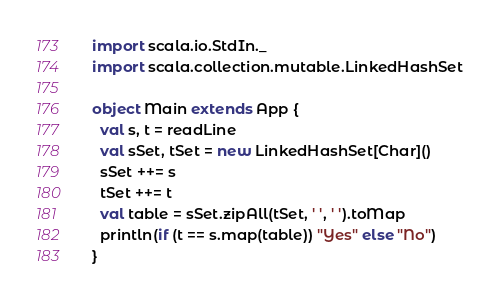<code> <loc_0><loc_0><loc_500><loc_500><_Scala_>import scala.io.StdIn._
import scala.collection.mutable.LinkedHashSet

object Main extends App {
  val s, t = readLine
  val sSet, tSet = new LinkedHashSet[Char]()
  sSet ++= s
  tSet ++= t
  val table = sSet.zipAll(tSet, ' ', ' ').toMap
  println(if (t == s.map(table)) "Yes" else "No")
}</code> 